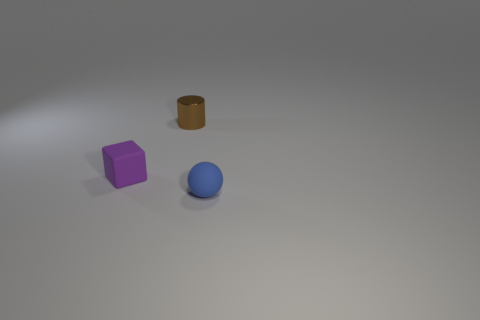Add 3 small purple matte blocks. How many objects exist? 6 Subtract all cylinders. How many objects are left? 2 Subtract all blue rubber spheres. Subtract all blue things. How many objects are left? 1 Add 1 small blue rubber things. How many small blue rubber things are left? 2 Add 3 metal things. How many metal things exist? 4 Subtract 0 cyan cylinders. How many objects are left? 3 